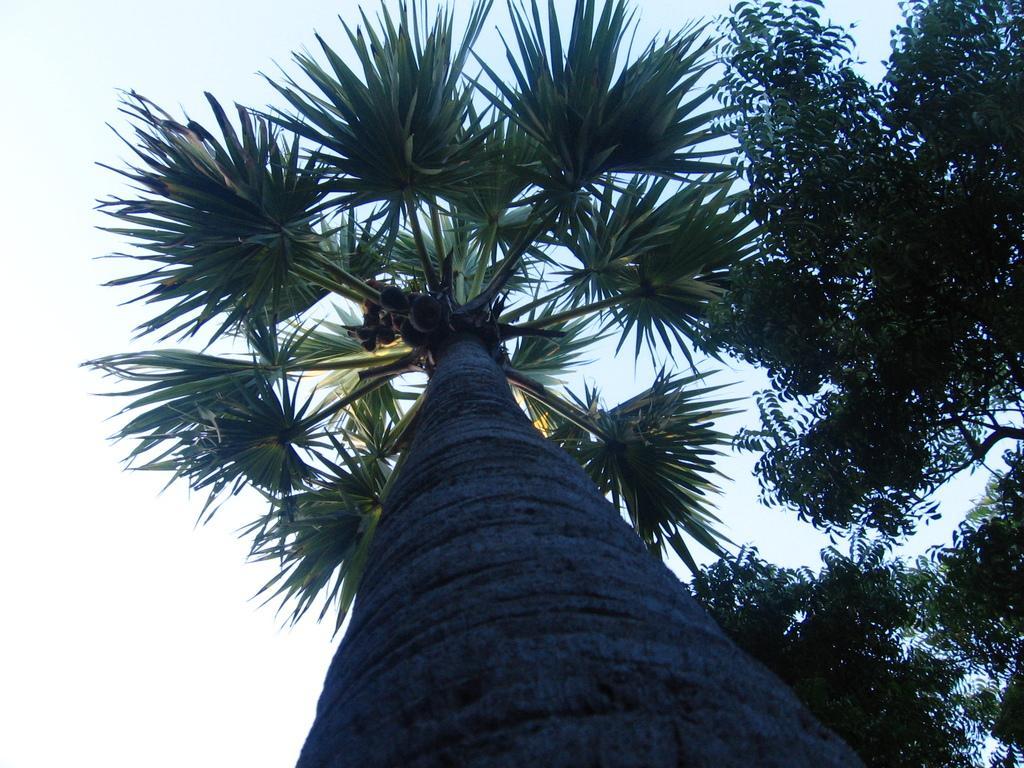Can you describe this image briefly? In the image there is a palm tree in the middle with neem tree beside it and above its sky. 